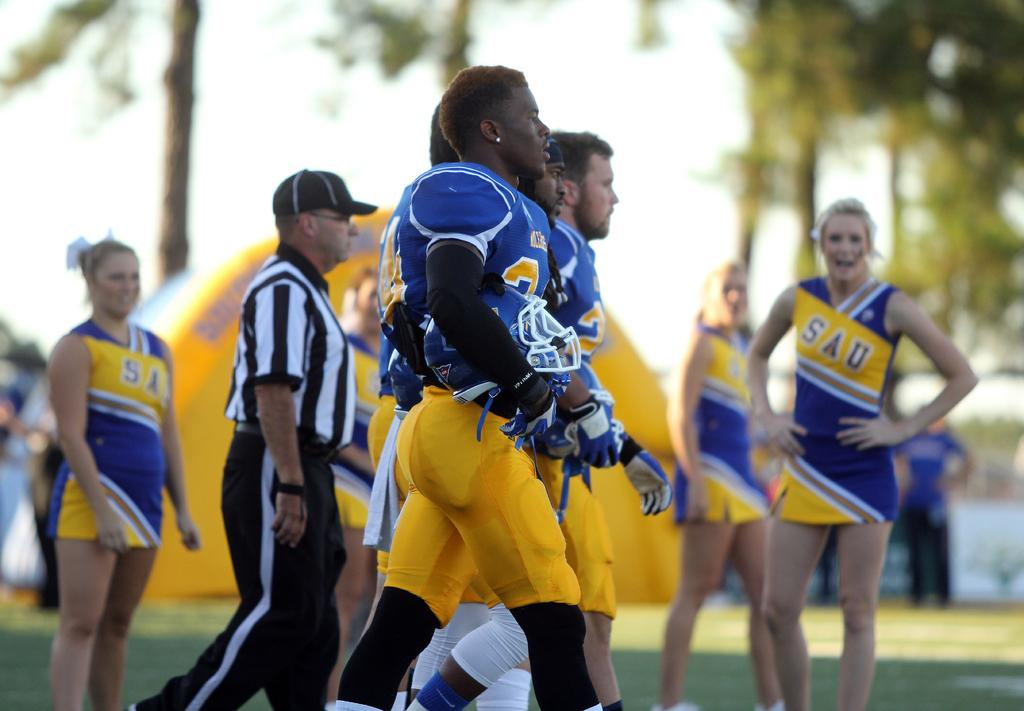<image>
Present a compact description of the photo's key features. SAU football players walk onto the field with cheerleaders watching. 